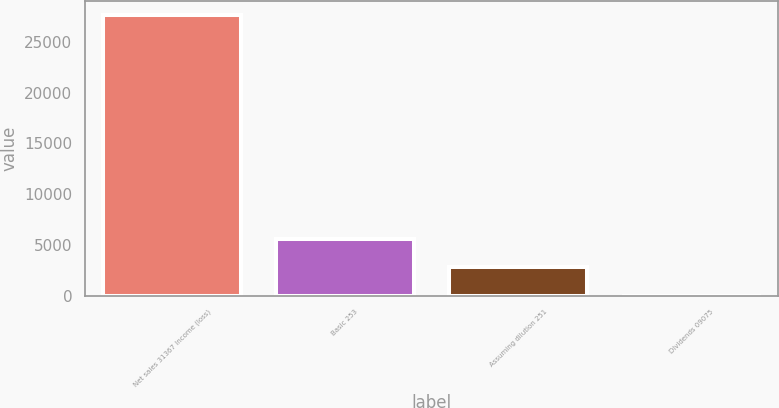<chart> <loc_0><loc_0><loc_500><loc_500><bar_chart><fcel>Net sales 31367 Income (loss)<fcel>Basic 253<fcel>Assuming dilution 251<fcel>Dividends 09075<nl><fcel>27652<fcel>5531.06<fcel>2765.94<fcel>0.82<nl></chart> 